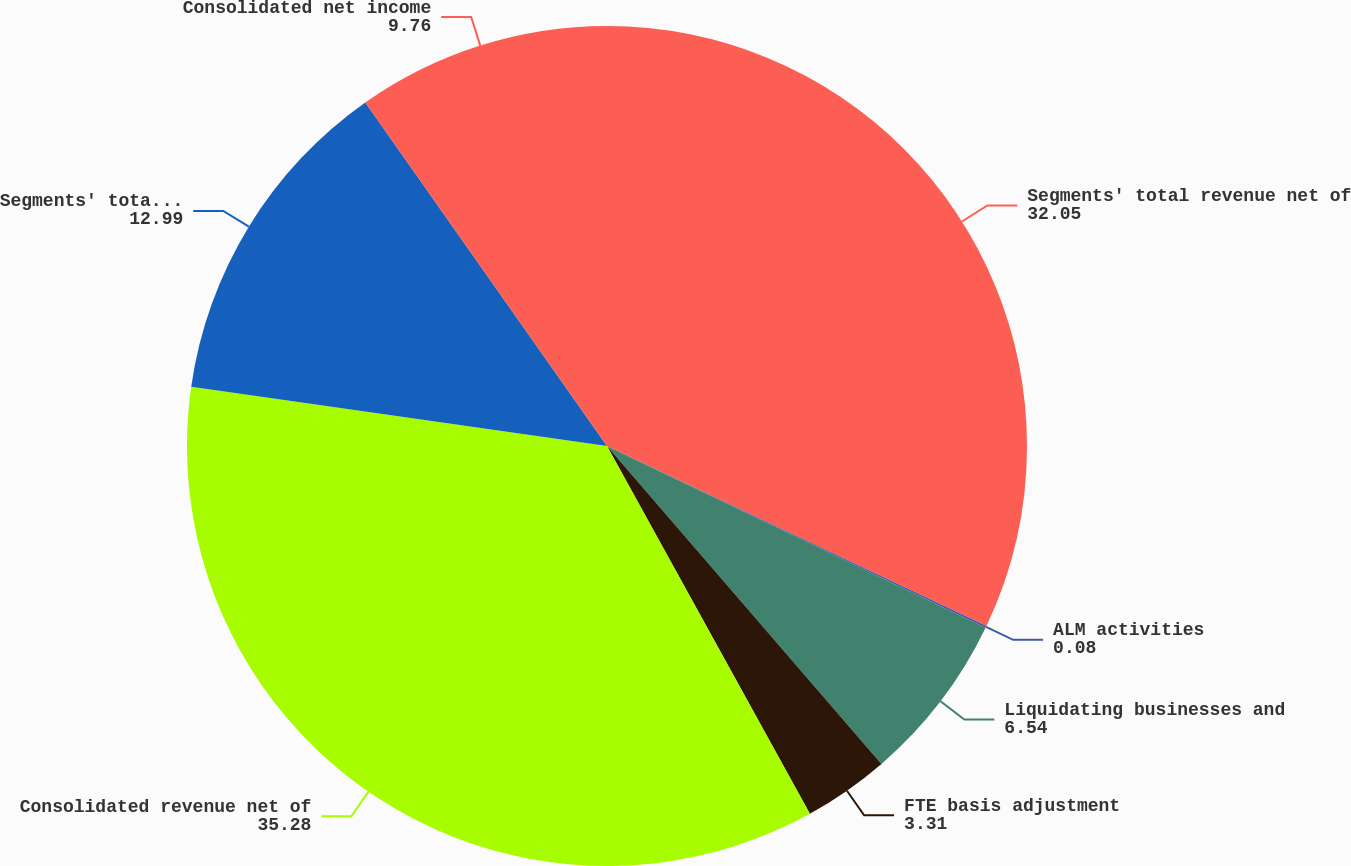<chart> <loc_0><loc_0><loc_500><loc_500><pie_chart><fcel>Segments' total revenue net of<fcel>ALM activities<fcel>Liquidating businesses and<fcel>FTE basis adjustment<fcel>Consolidated revenue net of<fcel>Segments' total net income<fcel>Consolidated net income<nl><fcel>32.05%<fcel>0.08%<fcel>6.54%<fcel>3.31%<fcel>35.28%<fcel>12.99%<fcel>9.76%<nl></chart> 